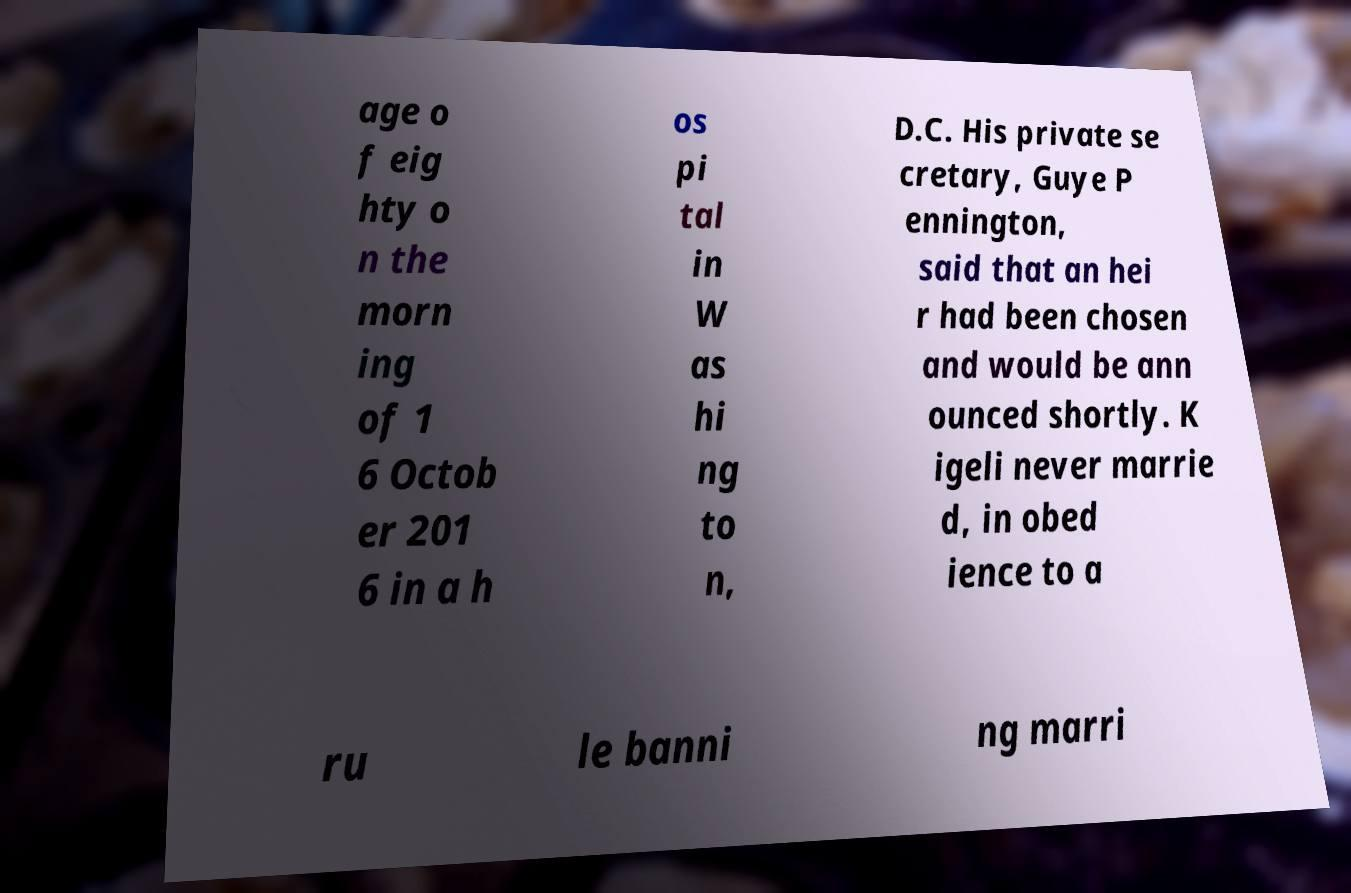There's text embedded in this image that I need extracted. Can you transcribe it verbatim? age o f eig hty o n the morn ing of 1 6 Octob er 201 6 in a h os pi tal in W as hi ng to n, D.C. His private se cretary, Guye P ennington, said that an hei r had been chosen and would be ann ounced shortly. K igeli never marrie d, in obed ience to a ru le banni ng marri 